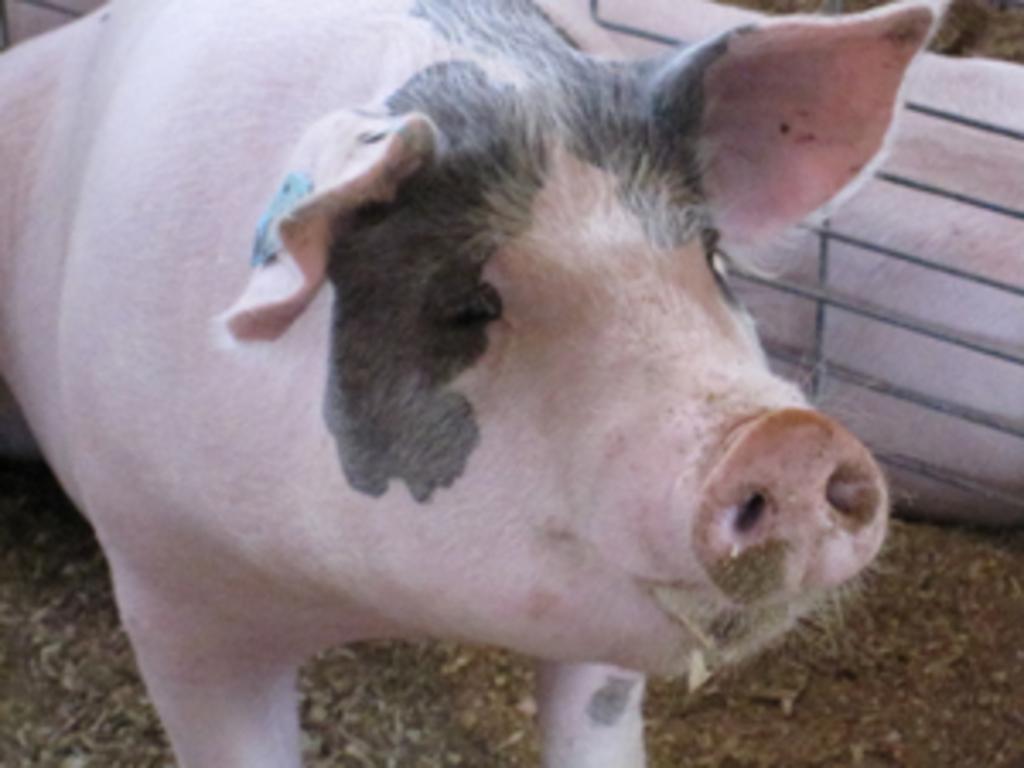In one or two sentences, can you explain what this image depicts? In this picture there is a pig. At the bottom there is soil. On the right there is another animal. 